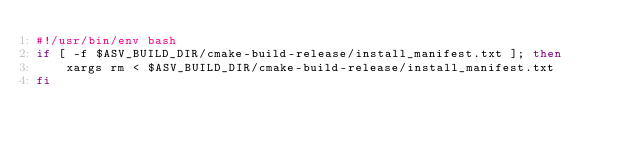<code> <loc_0><loc_0><loc_500><loc_500><_Bash_>#!/usr/bin/env bash
if [ -f $ASV_BUILD_DIR/cmake-build-release/install_manifest.txt ]; then
    xargs rm < $ASV_BUILD_DIR/cmake-build-release/install_manifest.txt
fi</code> 